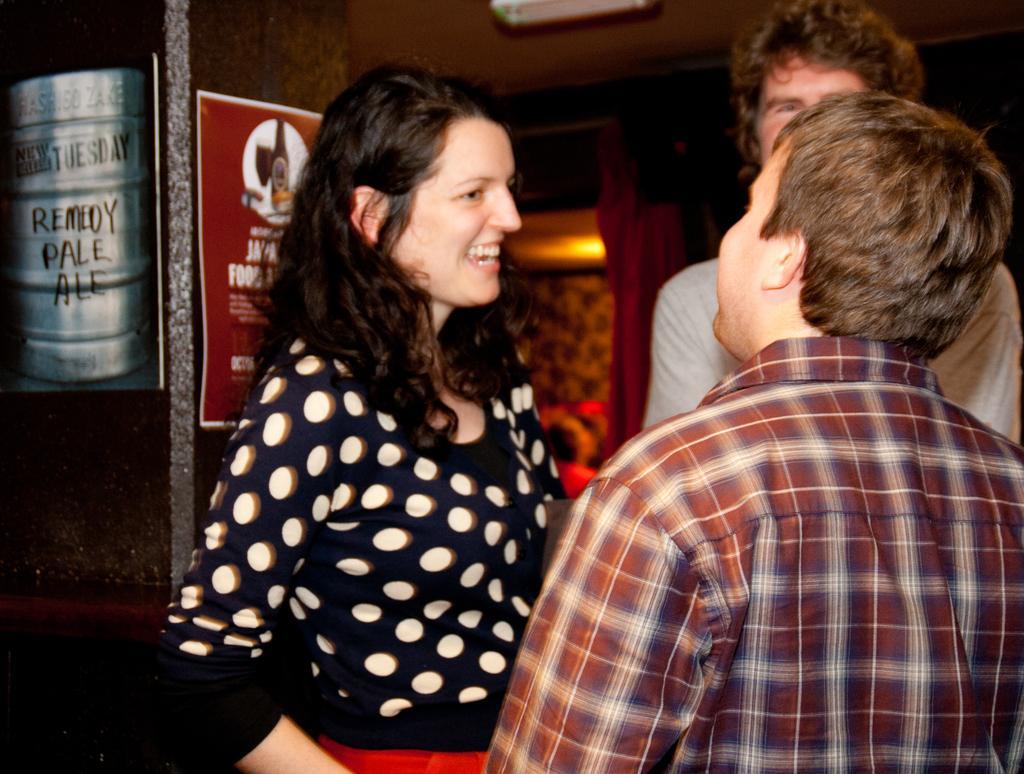Could you give a brief overview of what you see in this image? This image consist of persons standing. The woman standing in the center is smiling. On the left side there is banner on the wall with some text written on it and in the background there is a wall and a curtain. 